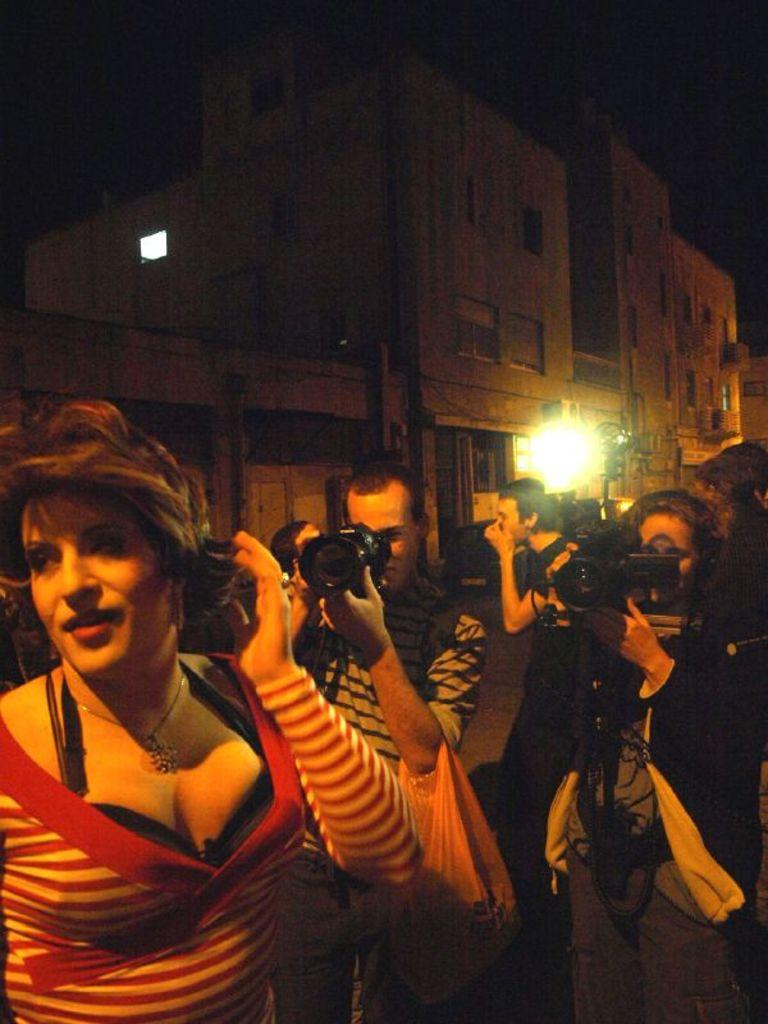How many people are in the image? There is a group of people in the image. What are two people in the group doing? Two people in the group are holding cameras. What can be seen in the background of the image? There are buildings in the background of the image. How would you describe the lighting in the image? There is a light visible in the image. What is the color of the background in the image? The background of the image is dark. How many goldfish are swimming in the image? There are no goldfish present in the image. What type of expansion is visible in the image? There is no expansion visible in the image. 